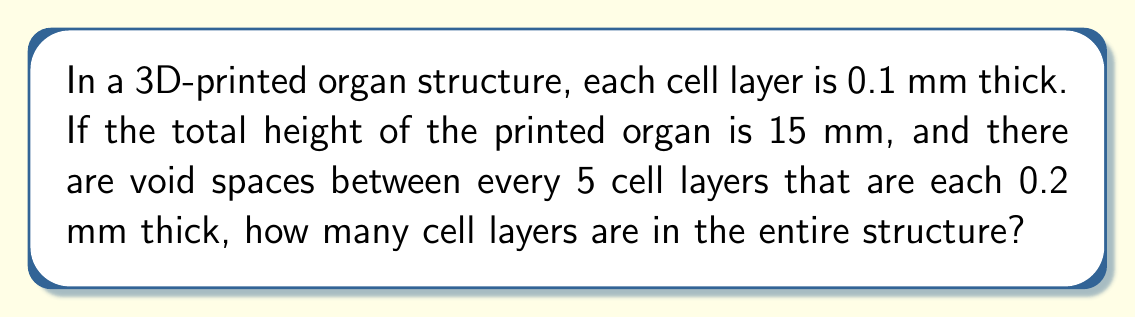Show me your answer to this math problem. Let's approach this step-by-step:

1) First, let's define our variables:
   $h$ = total height of the organ = 15 mm
   $t$ = thickness of each cell layer = 0.1 mm
   $v$ = thickness of each void space = 0.2 mm
   $n$ = number of cell layers (what we're solving for)

2) We know that there's a void space after every 5 cell layers. So, we can group the structure into sets of 5 cell layers + 1 void space.

3) The height of each set is:
   $5t + v = 5(0.1) + 0.2 = 0.7$ mm

4) Let's call the number of complete sets $x$. We can find this by dividing the total height by the height of each set and rounding down:

   $x = \lfloor\frac{h}{5t + v}\rfloor = \lfloor\frac{15}{0.7}\rfloor = 21$

5) These 21 complete sets account for $21 * 5 = 105$ cell layers.

6) Now, we need to check if there are any remaining cell layers. The height used by the complete sets is:

   $21 * 0.7 = 14.7$ mm

7) The remaining height is:
   $15 - 14.7 = 0.3$ mm

8) This 0.3 mm can fit 3 more cell layers (each 0.1 mm thick).

9) Therefore, the total number of cell layers is:
   $n = (21 * 5) + 3 = 105 + 3 = 108$
Answer: 108 